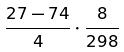Convert formula to latex. <formula><loc_0><loc_0><loc_500><loc_500>\frac { 2 7 - 7 4 } { 4 } \cdot \frac { 8 } { 2 9 8 }</formula> 